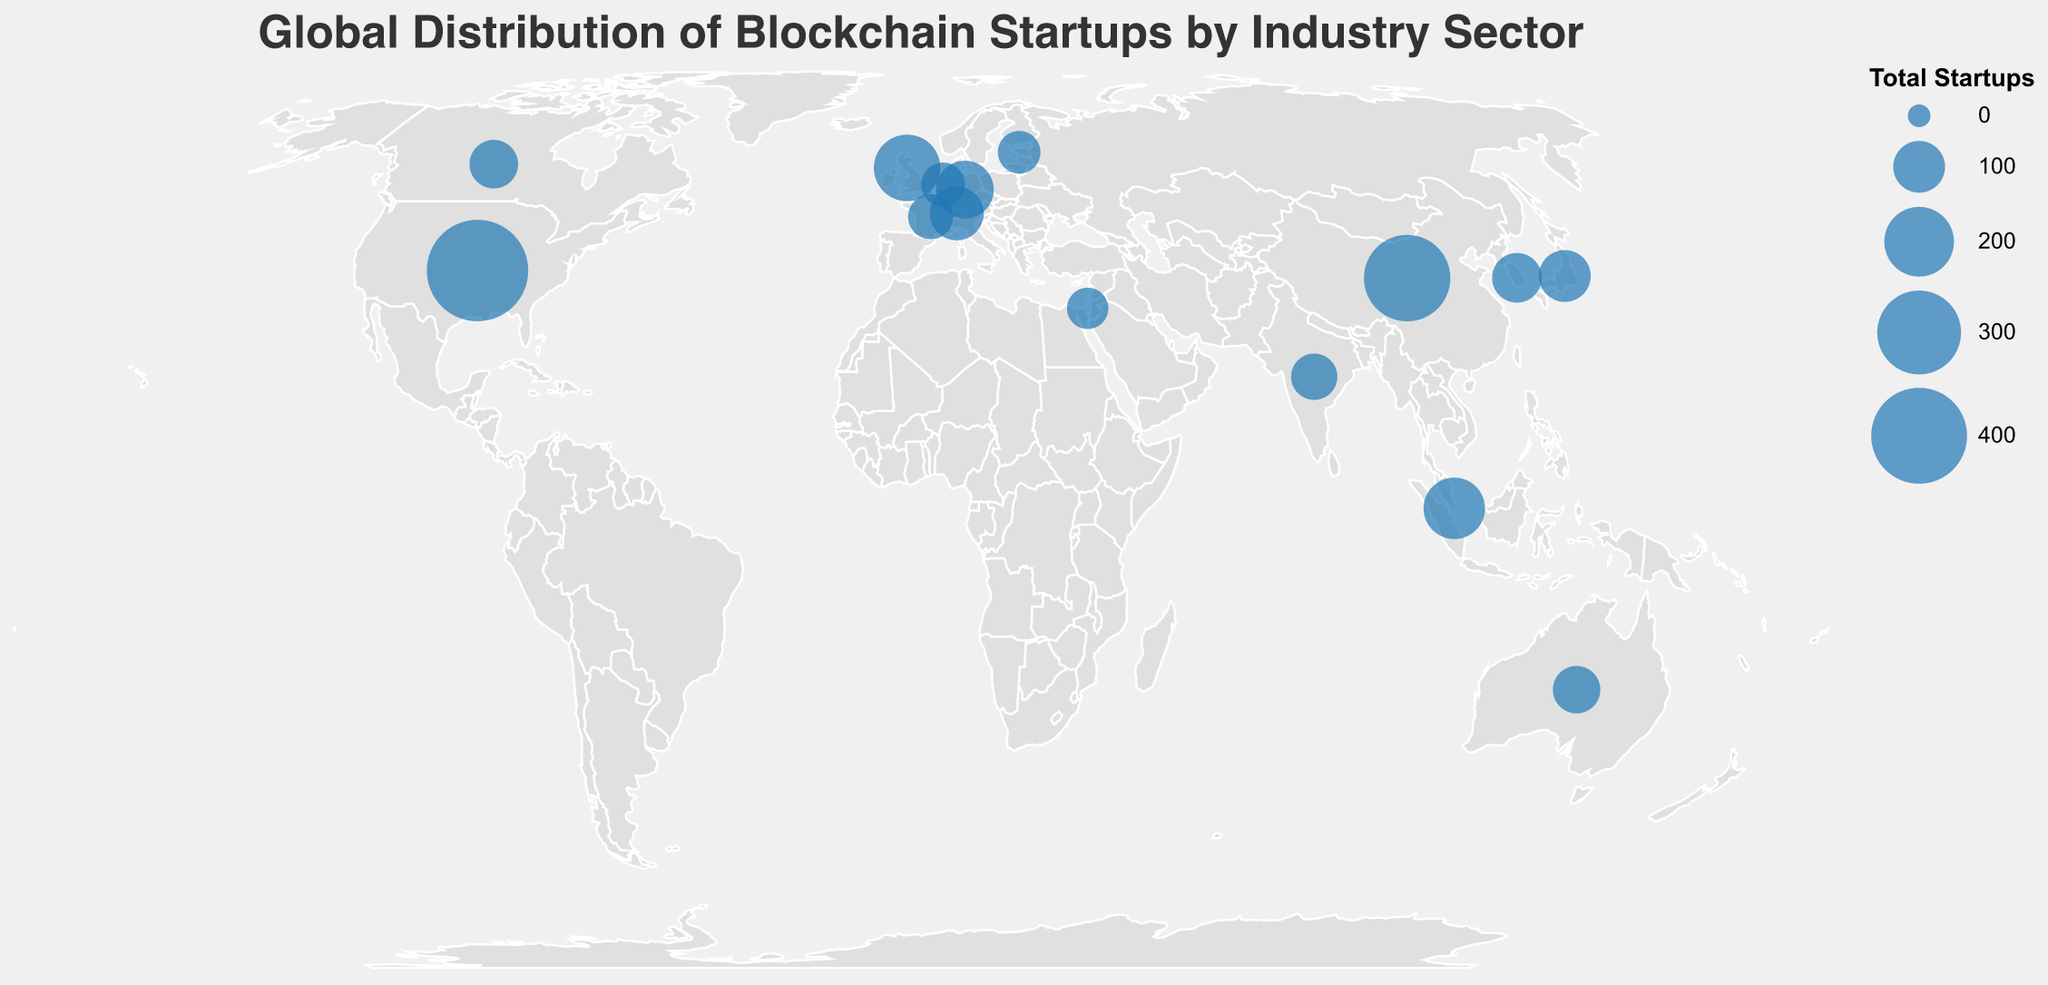What is the title of the figure? The title is usually located at the top of the figure. It reads "Global Distribution of Blockchain Startups by Industry Sector".
Answer: "Global Distribution of Blockchain Startups by Industry Sector" How many countries are represented in the figure? You can count the number of circles on the map, each representing a different country.
Answer: 15 Which country has the highest number of blockchain startups? The size of the circle is indicative of the total number of startups. The largest circle represents the United States.
Answer: United States What is the range of sizes used for the circles representing the total number of startups? The figure notes that the size scale range for "Total Startups" is from 100 to 2000.
Answer: 100 to 2000 What is the average number of startups in the countries shown? Add the total startups for all countries and divide by the number of countries: (450 + 320 + 180 + 150 + 130 + 110 + 100 + 90 + 85 + 80 + 75 + 70 + 65 + 60 + 55) / 15 = 1420 / 15.
Answer: 94.67 Which country has the smallest number of blockchain startups, and how many are there? The smallest circle representation on the map corresponds to Israel with 55 startups.
Answer: Israel, 55 Considering only the finance sector, which country has the most startups? The data provides sector-specific numbers. The United States has the most finance-related startups with 180.
Answer: United States What is the total number of finance-related startups in China and the United Kingdom combined? Add the finance sector startups for both countries: 150 (China) + 80 (United Kingdom) = 230.
Answer: 230 Which two countries have the same number of gaming sector startups? By checking the data, France and Australia each have 10 gaming sector startups.
Answer: France and Australia How does the number of healthcare startups in Singapore compare to those in Germany? Singapore has 25 healthcare startups, while Germany has 20, so Singapore has more healthcare startups.
Answer: Singapore has more 